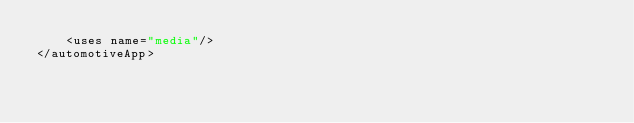Convert code to text. <code><loc_0><loc_0><loc_500><loc_500><_XML_>    <uses name="media"/>
</automotiveApp></code> 